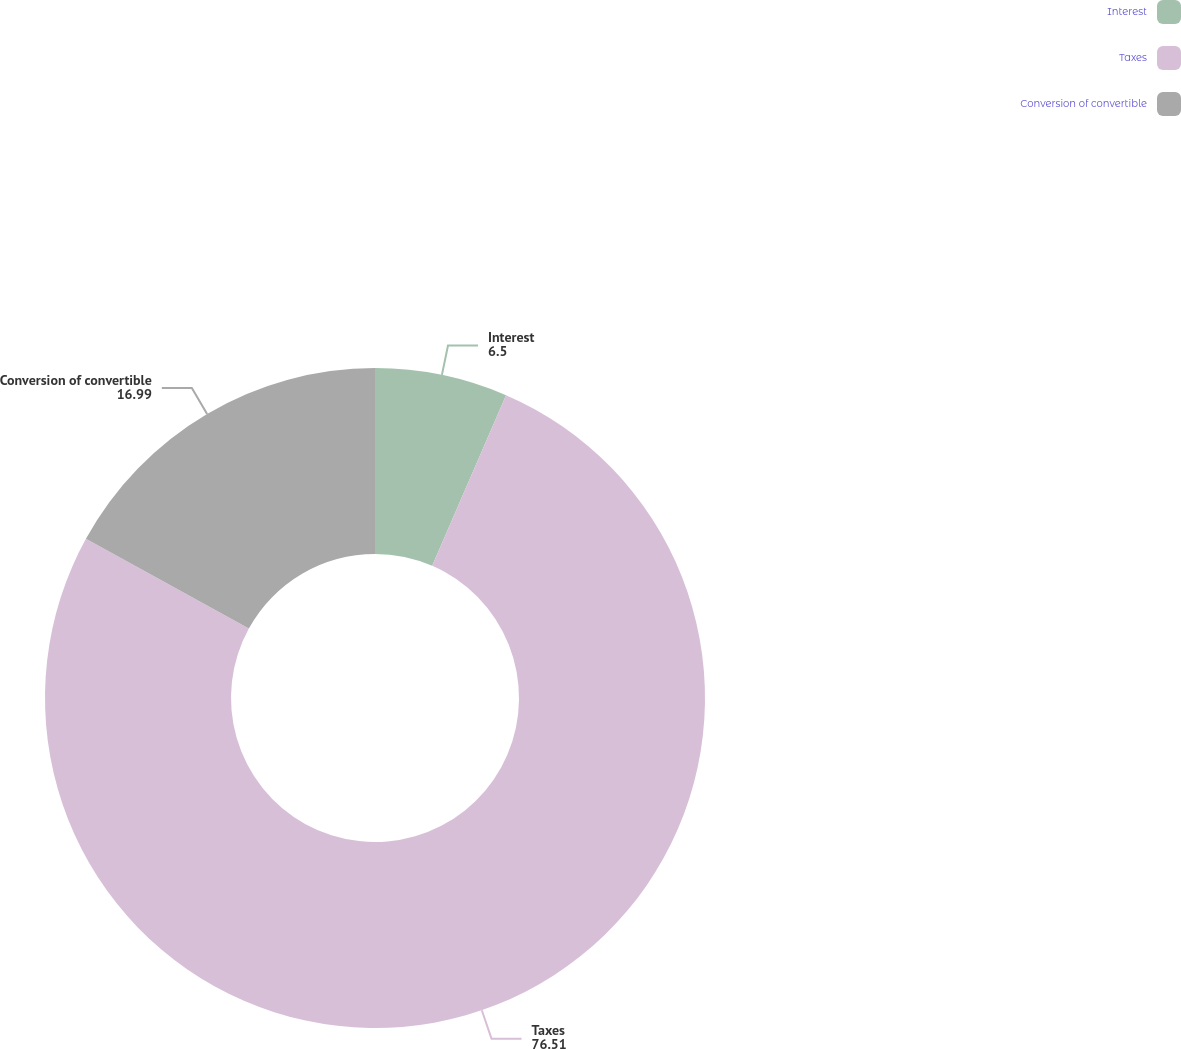<chart> <loc_0><loc_0><loc_500><loc_500><pie_chart><fcel>Interest<fcel>Taxes<fcel>Conversion of convertible<nl><fcel>6.5%<fcel>76.51%<fcel>16.99%<nl></chart> 